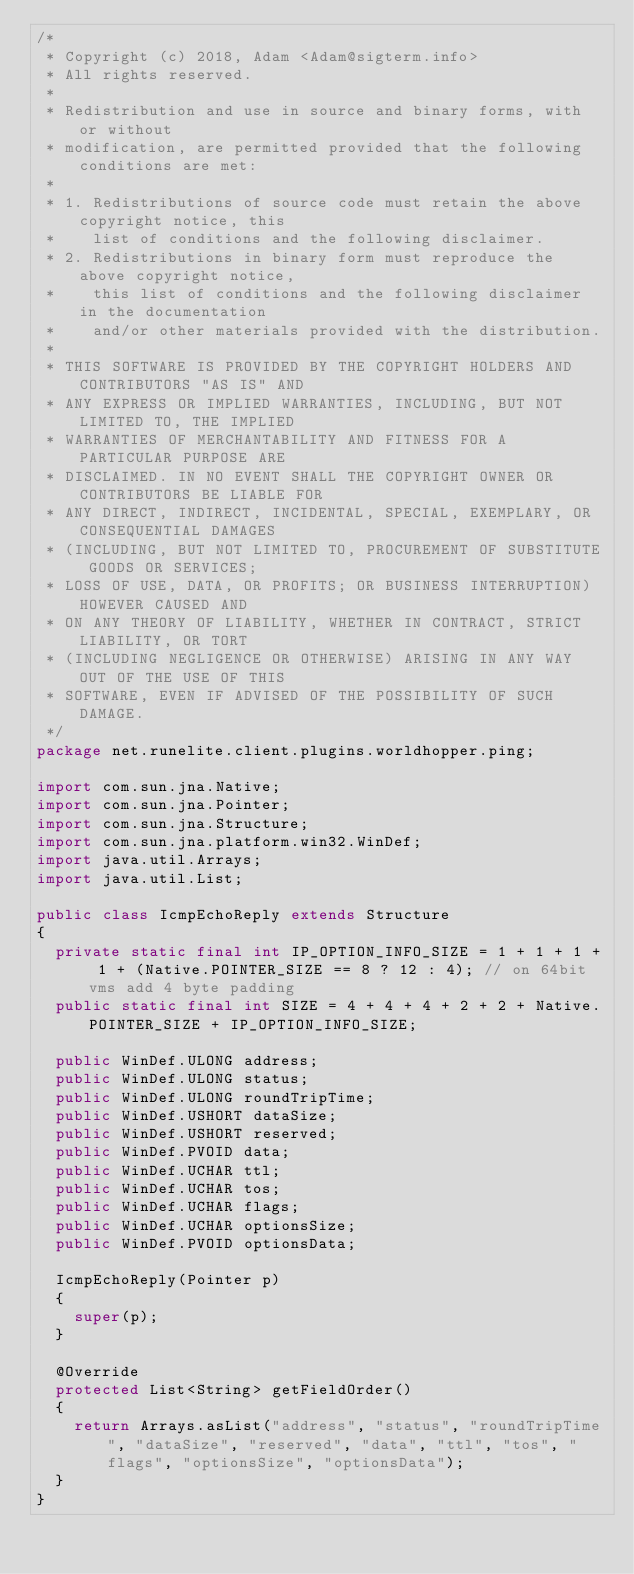<code> <loc_0><loc_0><loc_500><loc_500><_Java_>/*
 * Copyright (c) 2018, Adam <Adam@sigterm.info>
 * All rights reserved.
 *
 * Redistribution and use in source and binary forms, with or without
 * modification, are permitted provided that the following conditions are met:
 *
 * 1. Redistributions of source code must retain the above copyright notice, this
 *    list of conditions and the following disclaimer.
 * 2. Redistributions in binary form must reproduce the above copyright notice,
 *    this list of conditions and the following disclaimer in the documentation
 *    and/or other materials provided with the distribution.
 *
 * THIS SOFTWARE IS PROVIDED BY THE COPYRIGHT HOLDERS AND CONTRIBUTORS "AS IS" AND
 * ANY EXPRESS OR IMPLIED WARRANTIES, INCLUDING, BUT NOT LIMITED TO, THE IMPLIED
 * WARRANTIES OF MERCHANTABILITY AND FITNESS FOR A PARTICULAR PURPOSE ARE
 * DISCLAIMED. IN NO EVENT SHALL THE COPYRIGHT OWNER OR CONTRIBUTORS BE LIABLE FOR
 * ANY DIRECT, INDIRECT, INCIDENTAL, SPECIAL, EXEMPLARY, OR CONSEQUENTIAL DAMAGES
 * (INCLUDING, BUT NOT LIMITED TO, PROCUREMENT OF SUBSTITUTE GOODS OR SERVICES;
 * LOSS OF USE, DATA, OR PROFITS; OR BUSINESS INTERRUPTION) HOWEVER CAUSED AND
 * ON ANY THEORY OF LIABILITY, WHETHER IN CONTRACT, STRICT LIABILITY, OR TORT
 * (INCLUDING NEGLIGENCE OR OTHERWISE) ARISING IN ANY WAY OUT OF THE USE OF THIS
 * SOFTWARE, EVEN IF ADVISED OF THE POSSIBILITY OF SUCH DAMAGE.
 */
package net.runelite.client.plugins.worldhopper.ping;

import com.sun.jna.Native;
import com.sun.jna.Pointer;
import com.sun.jna.Structure;
import com.sun.jna.platform.win32.WinDef;
import java.util.Arrays;
import java.util.List;

public class IcmpEchoReply extends Structure
{
	private static final int IP_OPTION_INFO_SIZE = 1 + 1 + 1 + 1 + (Native.POINTER_SIZE == 8 ? 12 : 4); // on 64bit vms add 4 byte padding
	public static final int SIZE = 4 + 4 + 4 + 2 + 2 + Native.POINTER_SIZE + IP_OPTION_INFO_SIZE;

	public WinDef.ULONG address;
	public WinDef.ULONG status;
	public WinDef.ULONG roundTripTime;
	public WinDef.USHORT dataSize;
	public WinDef.USHORT reserved;
	public WinDef.PVOID data;
	public WinDef.UCHAR ttl;
	public WinDef.UCHAR tos;
	public WinDef.UCHAR flags;
	public WinDef.UCHAR optionsSize;
	public WinDef.PVOID optionsData;

	IcmpEchoReply(Pointer p)
	{
		super(p);
	}

	@Override
	protected List<String> getFieldOrder()
	{
		return Arrays.asList("address", "status", "roundTripTime", "dataSize", "reserved", "data", "ttl", "tos", "flags", "optionsSize", "optionsData");
	}
}
</code> 